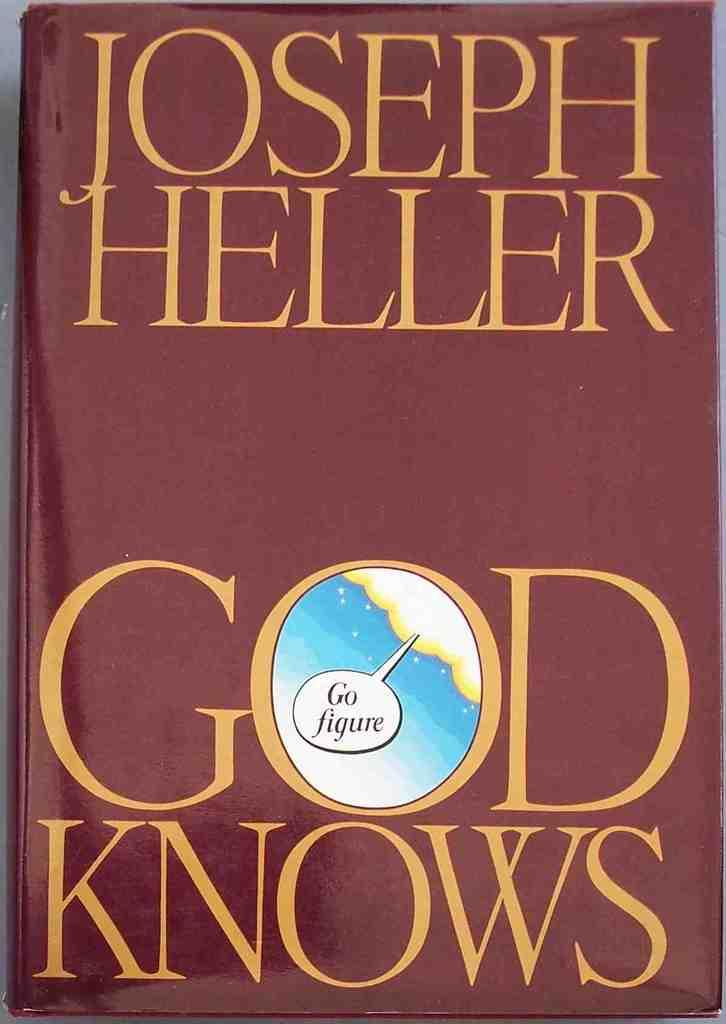<image>
Summarize the visual content of the image. A burgundy book jacket that is titled God Knows by Joseph Heller. 